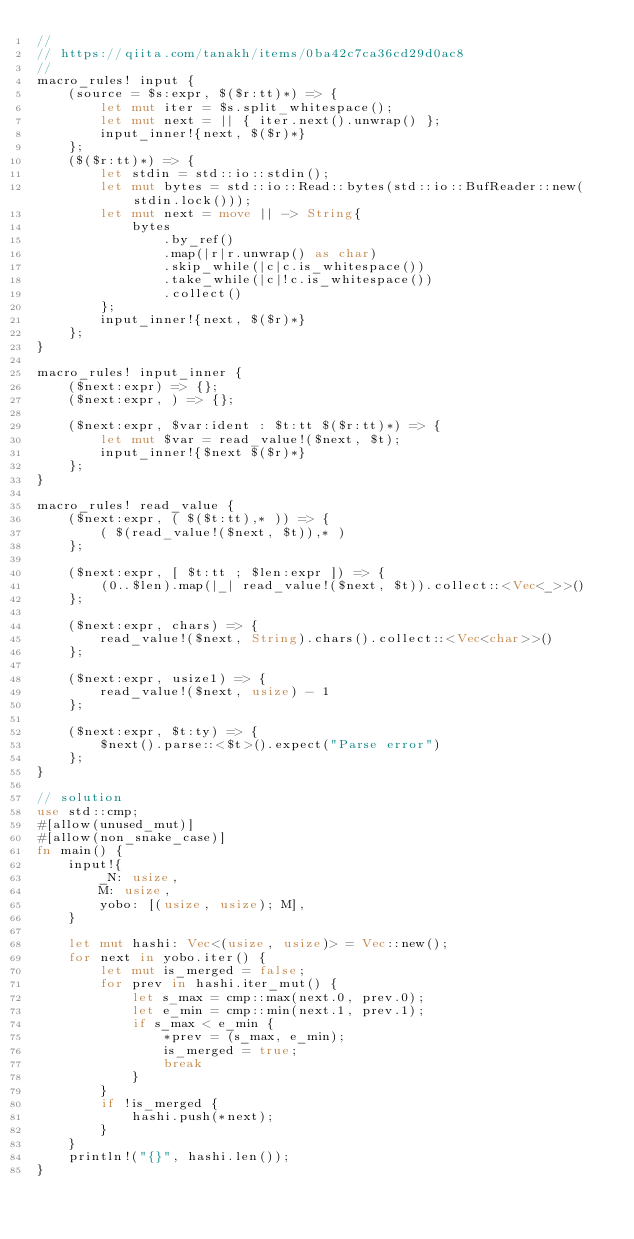<code> <loc_0><loc_0><loc_500><loc_500><_Rust_>//
// https://qiita.com/tanakh/items/0ba42c7ca36cd29d0ac8
//
macro_rules! input {
    (source = $s:expr, $($r:tt)*) => {
        let mut iter = $s.split_whitespace();
        let mut next = || { iter.next().unwrap() };
        input_inner!{next, $($r)*}
    };
    ($($r:tt)*) => {
        let stdin = std::io::stdin();
        let mut bytes = std::io::Read::bytes(std::io::BufReader::new(stdin.lock()));
        let mut next = move || -> String{
            bytes
                .by_ref()
                .map(|r|r.unwrap() as char)
                .skip_while(|c|c.is_whitespace())
                .take_while(|c|!c.is_whitespace())
                .collect()
        };
        input_inner!{next, $($r)*}
    };
}

macro_rules! input_inner {
    ($next:expr) => {};
    ($next:expr, ) => {};

    ($next:expr, $var:ident : $t:tt $($r:tt)*) => {
        let mut $var = read_value!($next, $t);
        input_inner!{$next $($r)*}
    };
}

macro_rules! read_value {
    ($next:expr, ( $($t:tt),* )) => {
        ( $(read_value!($next, $t)),* )
    };

    ($next:expr, [ $t:tt ; $len:expr ]) => {
        (0..$len).map(|_| read_value!($next, $t)).collect::<Vec<_>>()
    };

    ($next:expr, chars) => {
        read_value!($next, String).chars().collect::<Vec<char>>()
    };

    ($next:expr, usize1) => {
        read_value!($next, usize) - 1
    };

    ($next:expr, $t:ty) => {
        $next().parse::<$t>().expect("Parse error")
    };
}

// solution 
use std::cmp;
#[allow(unused_mut)]
#[allow(non_snake_case)]
fn main() {
    input!{
        _N: usize,
        M: usize,
        yobo: [(usize, usize); M],
    }

    let mut hashi: Vec<(usize, usize)> = Vec::new();
    for next in yobo.iter() {
        let mut is_merged = false;
        for prev in hashi.iter_mut() {
            let s_max = cmp::max(next.0, prev.0);
            let e_min = cmp::min(next.1, prev.1);
            if s_max < e_min {
                *prev = (s_max, e_min);
                is_merged = true;
                break
            }
        }
        if !is_merged {
            hashi.push(*next);
        }
    }
    println!("{}", hashi.len());
}

</code> 